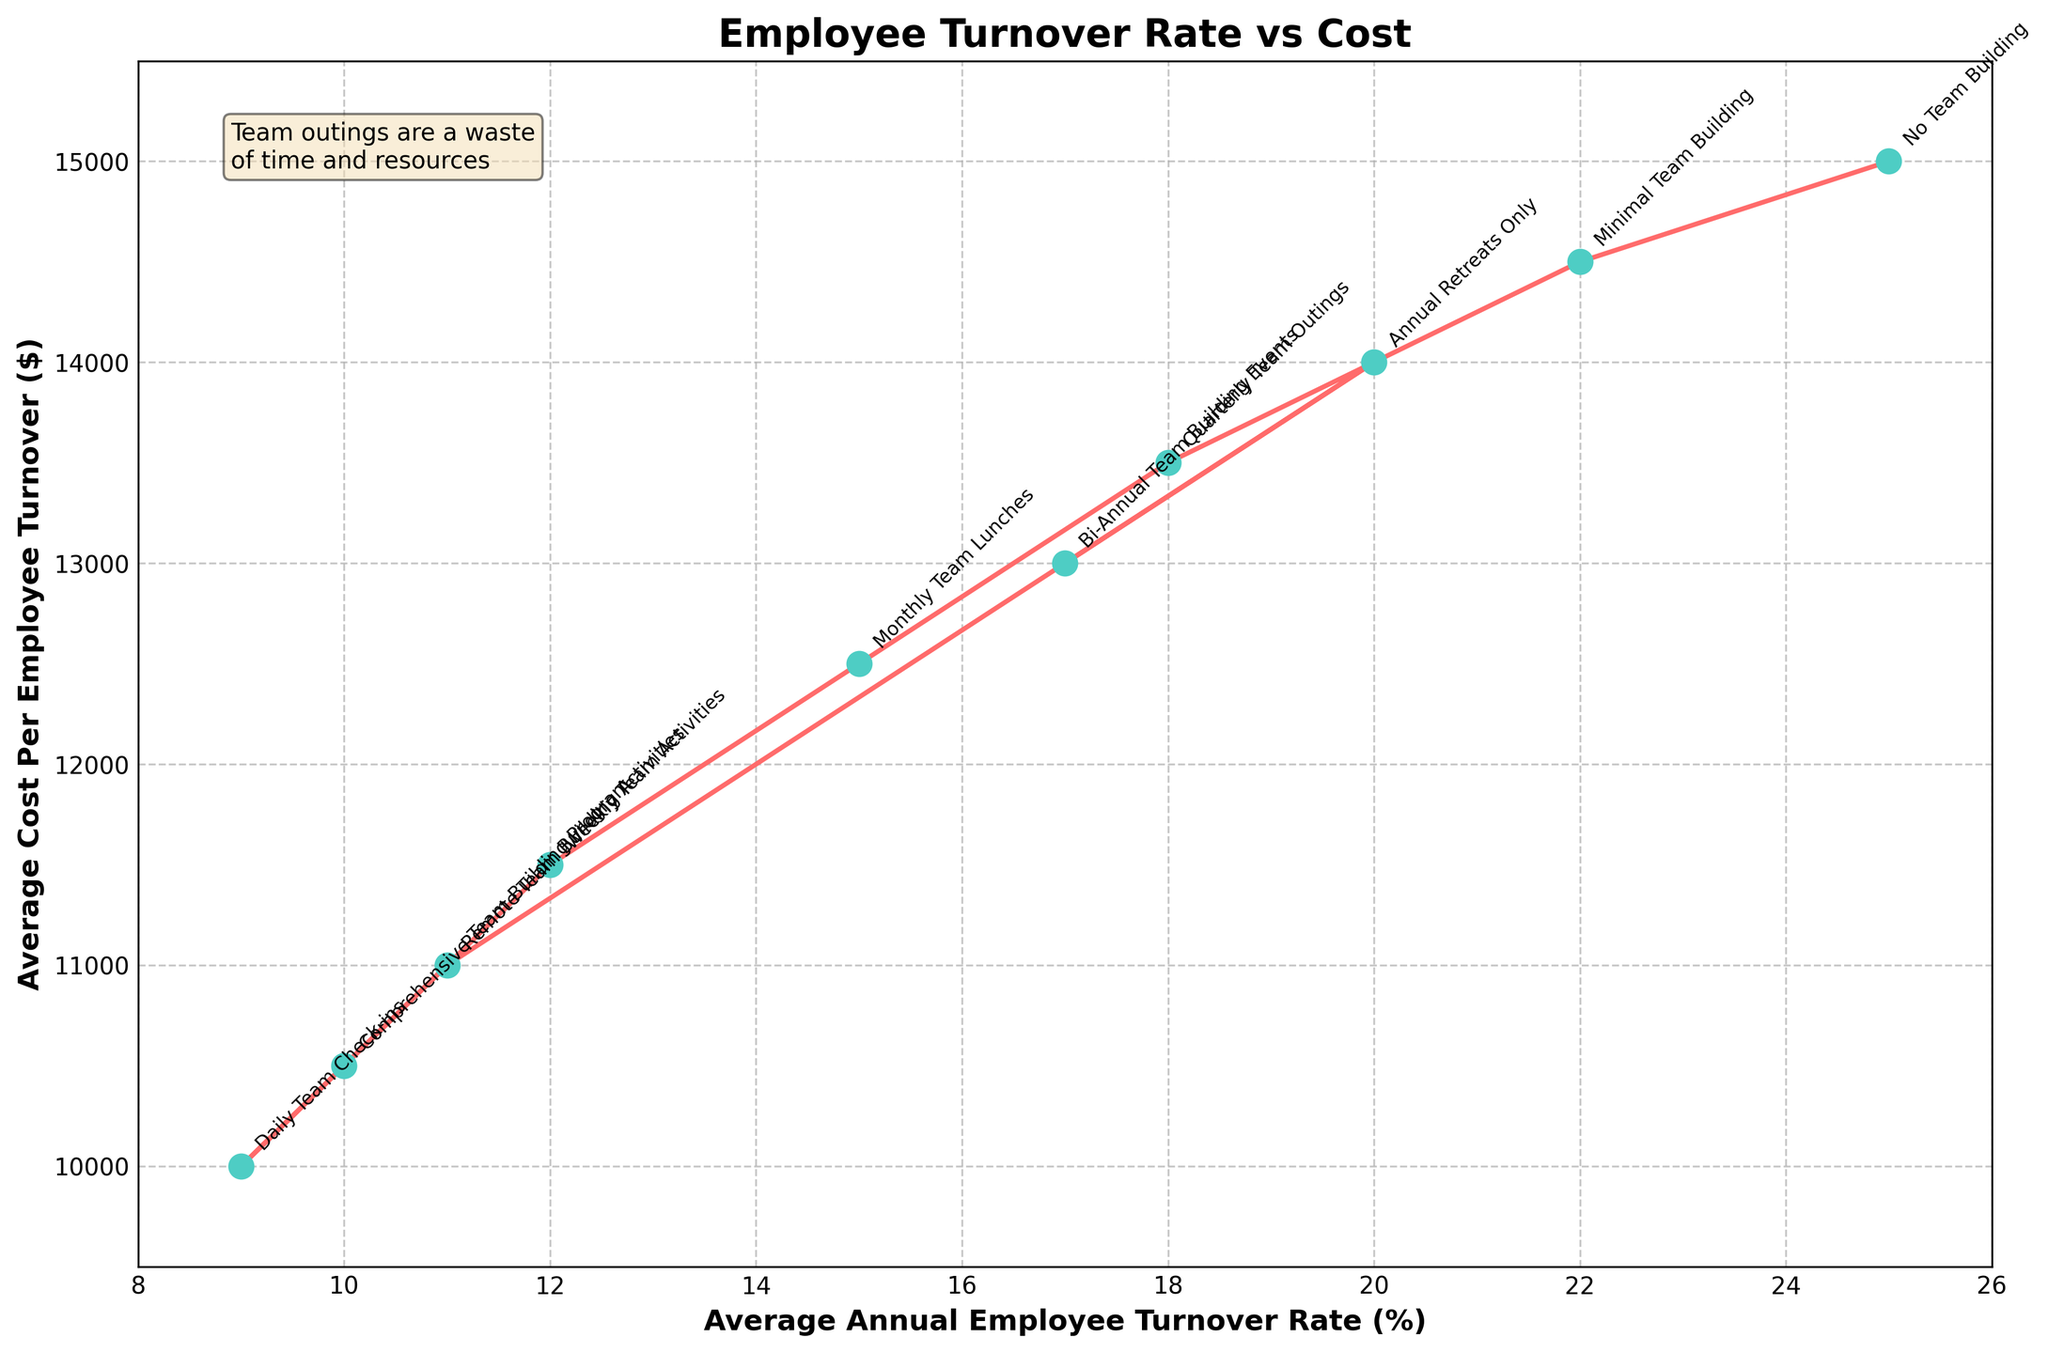Which company type has the highest average employee turnover rate? To determine which company type has the highest average turnover rate, check the x-axis for the highest percentage and refer to the corresponding label.
Answer: No Team Building What is the average cost per employee turnover for a company with Quarterly Team Outings? Locate "Quarterly Team Outings" on the plot. Then check the y-axis for the average cost per employee turnover value.
Answer: $13,500 How many percentage points lower is the turnover rate for companies with Comprehensive Team Building Program compared to those with No Team Building? Find the turnover rates for both "Comprehensive Team Building Program" (10%) and "No Team Building" (25%). Subtract the smaller from the larger value: 25% - 10% = 15%.
Answer: 15% Which company type has the lowest average cost per employee turnover? On the y-axis, look for the lowest value and reference the corresponding label on the plot.
Answer: Daily Team Check-ins How much less does a company with Weekly Team Activities spend per turnover compared to a company with Annual Retreats Only? Locate both "Weekly Team Activities" ($11,500) and "Annual Retreats Only" ($14,000) on the y-axis. Subtract the smaller value from the larger: $14,000 - $11,500 = $2,500.
Answer: $2,500 What is the trend between employee turnover rate and cost per employee turnover? Observe the overall direction of the line on the plot. It generally shows that as the turnover rate decreases (leftwards), the cost per turnover also decreases (downwards).
Answer: Both decrease together Is there any company type with a lower turnover rate than Remote Team Building Activities (11%) but with higher costs? Identify company types to the left of "Remote Team Building Activities" (11%) on the x-axis and check if their y-values are higher than $11,000. The "Daily Team Check-ins" has a turnover rate of 9% and cost $10,000 which is not higher. So, the answer is no.
Answer: No What is the average cost per employee turnover for company types with more than 20% turnover rates? Identify company types with turnover rates greater than 20%: "No Team Building" ($15,000) and "Annual Retreats Only" ($14,000). Then, average these costs: ($15,000 + $14,000) / 2 = $14,500.
Answer: $14,500 